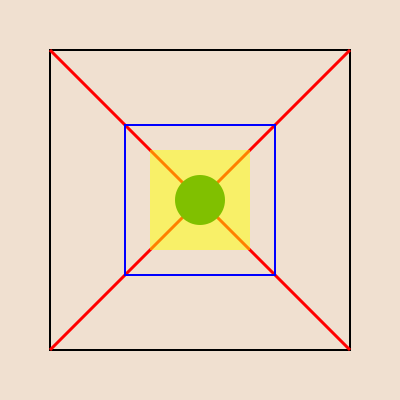Analyze the geometric patterns in this traditional Balkan textile design. What is the significance of the central motif, and how does it relate to the overall symmetry of the design? Additionally, calculate the ratio of the area of the innermost square to the area of the outermost square. 1. Symmetry analysis:
   - The design exhibits rotational symmetry of order 4 around the center point.
   - It also has reflection symmetry across both diagonals and the vertical and horizontal axes.

2. Central motif:
   - The green circle at the center represents the "eye" or "sun" motif common in Balkan textiles.
   - It serves as a focal point and balances the design.

3. Relationship to overall symmetry:
   - The central motif reinforces the rotational and reflectional symmetry.
   - Its circular shape contrasts with the angular elements, creating visual interest.

4. Geometric elements:
   - Outermost square (black): Represents the border or frame of the design.
   - Red diagonals: Create four triangular sections, typical in Balkan patterns.
   - Blue square: Acts as a secondary frame, emphasizing the central area.
   - Yellow square: Provides a background for the central motif.

5. Area ratio calculation:
   - Let the side length of the outermost square be $s$.
   - The innermost (yellow) square has a side length of $\frac{s}{4}$.
   - Area of outermost square: $A_1 = s^2$
   - Area of innermost square: $A_2 = (\frac{s}{4})^2 = \frac{s^2}{16}$
   - Ratio: $\frac{A_2}{A_1} = \frac{\frac{s^2}{16}}{s^2} = \frac{1}{16}$

The ratio of $1:16$ demonstrates the fractal-like nature of the design, where smaller elements echo the structure of larger ones.
Answer: The central circular motif represents the "eye" or "sun", reinforcing overall symmetry. The area ratio of innermost to outermost square is $1:16$. 